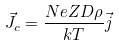<formula> <loc_0><loc_0><loc_500><loc_500>\vec { J } _ { c } = \frac { N e Z D \rho } { k T } \vec { j }</formula> 